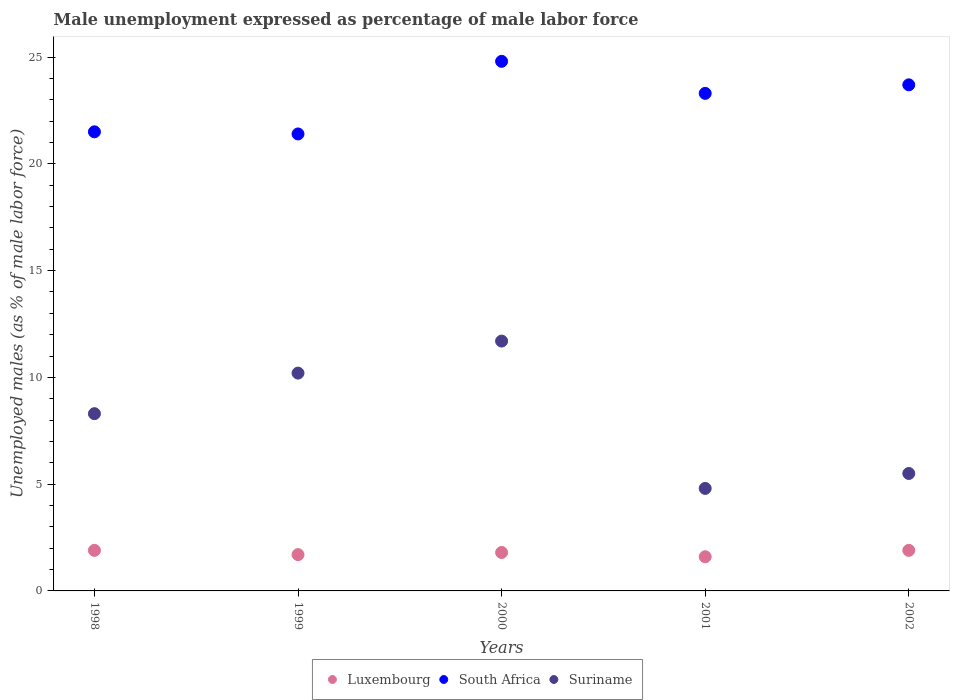What is the unemployment in males in in Suriname in 1999?
Your response must be concise. 10.2. Across all years, what is the maximum unemployment in males in in Luxembourg?
Offer a terse response. 1.9. Across all years, what is the minimum unemployment in males in in Suriname?
Your answer should be compact. 4.8. What is the total unemployment in males in in Luxembourg in the graph?
Your response must be concise. 8.9. What is the difference between the unemployment in males in in Luxembourg in 1998 and that in 2000?
Ensure brevity in your answer.  0.1. What is the difference between the unemployment in males in in Suriname in 1998 and the unemployment in males in in Luxembourg in 2002?
Your response must be concise. 6.4. What is the average unemployment in males in in Suriname per year?
Offer a terse response. 8.1. In the year 2000, what is the difference between the unemployment in males in in South Africa and unemployment in males in in Suriname?
Give a very brief answer. 13.1. What is the ratio of the unemployment in males in in Suriname in 1998 to that in 2001?
Ensure brevity in your answer.  1.73. Is the unemployment in males in in South Africa in 2000 less than that in 2002?
Your answer should be compact. No. What is the difference between the highest and the second highest unemployment in males in in Suriname?
Give a very brief answer. 1.5. What is the difference between the highest and the lowest unemployment in males in in South Africa?
Your answer should be very brief. 3.4. In how many years, is the unemployment in males in in Suriname greater than the average unemployment in males in in Suriname taken over all years?
Keep it short and to the point. 3. Is it the case that in every year, the sum of the unemployment in males in in Suriname and unemployment in males in in South Africa  is greater than the unemployment in males in in Luxembourg?
Provide a succinct answer. Yes. Is the unemployment in males in in Suriname strictly less than the unemployment in males in in South Africa over the years?
Offer a terse response. Yes. How many dotlines are there?
Provide a short and direct response. 3. How many years are there in the graph?
Provide a short and direct response. 5. What is the difference between two consecutive major ticks on the Y-axis?
Provide a short and direct response. 5. Are the values on the major ticks of Y-axis written in scientific E-notation?
Provide a succinct answer. No. Does the graph contain grids?
Your answer should be very brief. No. Where does the legend appear in the graph?
Give a very brief answer. Bottom center. What is the title of the graph?
Provide a short and direct response. Male unemployment expressed as percentage of male labor force. Does "Cameroon" appear as one of the legend labels in the graph?
Provide a succinct answer. No. What is the label or title of the Y-axis?
Provide a succinct answer. Unemployed males (as % of male labor force). What is the Unemployed males (as % of male labor force) of Luxembourg in 1998?
Your answer should be very brief. 1.9. What is the Unemployed males (as % of male labor force) in South Africa in 1998?
Your answer should be very brief. 21.5. What is the Unemployed males (as % of male labor force) in Suriname in 1998?
Ensure brevity in your answer.  8.3. What is the Unemployed males (as % of male labor force) of Luxembourg in 1999?
Provide a succinct answer. 1.7. What is the Unemployed males (as % of male labor force) of South Africa in 1999?
Give a very brief answer. 21.4. What is the Unemployed males (as % of male labor force) of Suriname in 1999?
Provide a succinct answer. 10.2. What is the Unemployed males (as % of male labor force) of Luxembourg in 2000?
Your response must be concise. 1.8. What is the Unemployed males (as % of male labor force) of South Africa in 2000?
Keep it short and to the point. 24.8. What is the Unemployed males (as % of male labor force) in Suriname in 2000?
Keep it short and to the point. 11.7. What is the Unemployed males (as % of male labor force) of Luxembourg in 2001?
Your answer should be very brief. 1.6. What is the Unemployed males (as % of male labor force) in South Africa in 2001?
Provide a short and direct response. 23.3. What is the Unemployed males (as % of male labor force) of Suriname in 2001?
Your response must be concise. 4.8. What is the Unemployed males (as % of male labor force) in Luxembourg in 2002?
Your answer should be very brief. 1.9. What is the Unemployed males (as % of male labor force) of South Africa in 2002?
Offer a terse response. 23.7. What is the Unemployed males (as % of male labor force) in Suriname in 2002?
Your answer should be compact. 5.5. Across all years, what is the maximum Unemployed males (as % of male labor force) in Luxembourg?
Offer a very short reply. 1.9. Across all years, what is the maximum Unemployed males (as % of male labor force) in South Africa?
Your response must be concise. 24.8. Across all years, what is the maximum Unemployed males (as % of male labor force) in Suriname?
Your response must be concise. 11.7. Across all years, what is the minimum Unemployed males (as % of male labor force) of Luxembourg?
Ensure brevity in your answer.  1.6. Across all years, what is the minimum Unemployed males (as % of male labor force) of South Africa?
Provide a short and direct response. 21.4. Across all years, what is the minimum Unemployed males (as % of male labor force) in Suriname?
Your answer should be compact. 4.8. What is the total Unemployed males (as % of male labor force) in Luxembourg in the graph?
Your response must be concise. 8.9. What is the total Unemployed males (as % of male labor force) in South Africa in the graph?
Provide a succinct answer. 114.7. What is the total Unemployed males (as % of male labor force) of Suriname in the graph?
Give a very brief answer. 40.5. What is the difference between the Unemployed males (as % of male labor force) in South Africa in 1998 and that in 1999?
Ensure brevity in your answer.  0.1. What is the difference between the Unemployed males (as % of male labor force) of Luxembourg in 1998 and that in 2001?
Ensure brevity in your answer.  0.3. What is the difference between the Unemployed males (as % of male labor force) in Suriname in 1998 and that in 2001?
Your response must be concise. 3.5. What is the difference between the Unemployed males (as % of male labor force) of Luxembourg in 1999 and that in 2000?
Keep it short and to the point. -0.1. What is the difference between the Unemployed males (as % of male labor force) of Suriname in 1999 and that in 2001?
Offer a terse response. 5.4. What is the difference between the Unemployed males (as % of male labor force) in Luxembourg in 1999 and that in 2002?
Your answer should be very brief. -0.2. What is the difference between the Unemployed males (as % of male labor force) of South Africa in 2000 and that in 2001?
Offer a terse response. 1.5. What is the difference between the Unemployed males (as % of male labor force) in Luxembourg in 2000 and that in 2002?
Provide a succinct answer. -0.1. What is the difference between the Unemployed males (as % of male labor force) of Suriname in 2000 and that in 2002?
Your answer should be very brief. 6.2. What is the difference between the Unemployed males (as % of male labor force) of South Africa in 2001 and that in 2002?
Provide a short and direct response. -0.4. What is the difference between the Unemployed males (as % of male labor force) of Suriname in 2001 and that in 2002?
Offer a very short reply. -0.7. What is the difference between the Unemployed males (as % of male labor force) in Luxembourg in 1998 and the Unemployed males (as % of male labor force) in South Africa in 1999?
Your answer should be very brief. -19.5. What is the difference between the Unemployed males (as % of male labor force) in South Africa in 1998 and the Unemployed males (as % of male labor force) in Suriname in 1999?
Your answer should be compact. 11.3. What is the difference between the Unemployed males (as % of male labor force) in Luxembourg in 1998 and the Unemployed males (as % of male labor force) in South Africa in 2000?
Your answer should be compact. -22.9. What is the difference between the Unemployed males (as % of male labor force) of Luxembourg in 1998 and the Unemployed males (as % of male labor force) of Suriname in 2000?
Your answer should be compact. -9.8. What is the difference between the Unemployed males (as % of male labor force) in South Africa in 1998 and the Unemployed males (as % of male labor force) in Suriname in 2000?
Offer a terse response. 9.8. What is the difference between the Unemployed males (as % of male labor force) of Luxembourg in 1998 and the Unemployed males (as % of male labor force) of South Africa in 2001?
Your answer should be compact. -21.4. What is the difference between the Unemployed males (as % of male labor force) in Luxembourg in 1998 and the Unemployed males (as % of male labor force) in Suriname in 2001?
Give a very brief answer. -2.9. What is the difference between the Unemployed males (as % of male labor force) in South Africa in 1998 and the Unemployed males (as % of male labor force) in Suriname in 2001?
Ensure brevity in your answer.  16.7. What is the difference between the Unemployed males (as % of male labor force) in Luxembourg in 1998 and the Unemployed males (as % of male labor force) in South Africa in 2002?
Provide a short and direct response. -21.8. What is the difference between the Unemployed males (as % of male labor force) of Luxembourg in 1999 and the Unemployed males (as % of male labor force) of South Africa in 2000?
Give a very brief answer. -23.1. What is the difference between the Unemployed males (as % of male labor force) in Luxembourg in 1999 and the Unemployed males (as % of male labor force) in Suriname in 2000?
Provide a succinct answer. -10. What is the difference between the Unemployed males (as % of male labor force) in Luxembourg in 1999 and the Unemployed males (as % of male labor force) in South Africa in 2001?
Ensure brevity in your answer.  -21.6. What is the difference between the Unemployed males (as % of male labor force) of Luxembourg in 1999 and the Unemployed males (as % of male labor force) of Suriname in 2001?
Ensure brevity in your answer.  -3.1. What is the difference between the Unemployed males (as % of male labor force) of Luxembourg in 2000 and the Unemployed males (as % of male labor force) of South Africa in 2001?
Provide a short and direct response. -21.5. What is the difference between the Unemployed males (as % of male labor force) of Luxembourg in 2000 and the Unemployed males (as % of male labor force) of South Africa in 2002?
Give a very brief answer. -21.9. What is the difference between the Unemployed males (as % of male labor force) of South Africa in 2000 and the Unemployed males (as % of male labor force) of Suriname in 2002?
Your response must be concise. 19.3. What is the difference between the Unemployed males (as % of male labor force) of Luxembourg in 2001 and the Unemployed males (as % of male labor force) of South Africa in 2002?
Keep it short and to the point. -22.1. What is the difference between the Unemployed males (as % of male labor force) in Luxembourg in 2001 and the Unemployed males (as % of male labor force) in Suriname in 2002?
Provide a succinct answer. -3.9. What is the average Unemployed males (as % of male labor force) in Luxembourg per year?
Your answer should be compact. 1.78. What is the average Unemployed males (as % of male labor force) of South Africa per year?
Make the answer very short. 22.94. In the year 1998, what is the difference between the Unemployed males (as % of male labor force) of Luxembourg and Unemployed males (as % of male labor force) of South Africa?
Give a very brief answer. -19.6. In the year 1998, what is the difference between the Unemployed males (as % of male labor force) of Luxembourg and Unemployed males (as % of male labor force) of Suriname?
Offer a very short reply. -6.4. In the year 1999, what is the difference between the Unemployed males (as % of male labor force) of Luxembourg and Unemployed males (as % of male labor force) of South Africa?
Your answer should be compact. -19.7. In the year 1999, what is the difference between the Unemployed males (as % of male labor force) of Luxembourg and Unemployed males (as % of male labor force) of Suriname?
Offer a terse response. -8.5. In the year 1999, what is the difference between the Unemployed males (as % of male labor force) in South Africa and Unemployed males (as % of male labor force) in Suriname?
Your response must be concise. 11.2. In the year 2000, what is the difference between the Unemployed males (as % of male labor force) in Luxembourg and Unemployed males (as % of male labor force) in South Africa?
Offer a very short reply. -23. In the year 2000, what is the difference between the Unemployed males (as % of male labor force) of South Africa and Unemployed males (as % of male labor force) of Suriname?
Offer a very short reply. 13.1. In the year 2001, what is the difference between the Unemployed males (as % of male labor force) of Luxembourg and Unemployed males (as % of male labor force) of South Africa?
Provide a short and direct response. -21.7. In the year 2001, what is the difference between the Unemployed males (as % of male labor force) in South Africa and Unemployed males (as % of male labor force) in Suriname?
Your response must be concise. 18.5. In the year 2002, what is the difference between the Unemployed males (as % of male labor force) in Luxembourg and Unemployed males (as % of male labor force) in South Africa?
Offer a very short reply. -21.8. What is the ratio of the Unemployed males (as % of male labor force) in Luxembourg in 1998 to that in 1999?
Keep it short and to the point. 1.12. What is the ratio of the Unemployed males (as % of male labor force) of South Africa in 1998 to that in 1999?
Provide a succinct answer. 1. What is the ratio of the Unemployed males (as % of male labor force) of Suriname in 1998 to that in 1999?
Your answer should be compact. 0.81. What is the ratio of the Unemployed males (as % of male labor force) of Luxembourg in 1998 to that in 2000?
Provide a short and direct response. 1.06. What is the ratio of the Unemployed males (as % of male labor force) in South Africa in 1998 to that in 2000?
Make the answer very short. 0.87. What is the ratio of the Unemployed males (as % of male labor force) of Suriname in 1998 to that in 2000?
Make the answer very short. 0.71. What is the ratio of the Unemployed males (as % of male labor force) in Luxembourg in 1998 to that in 2001?
Your answer should be very brief. 1.19. What is the ratio of the Unemployed males (as % of male labor force) in South Africa in 1998 to that in 2001?
Make the answer very short. 0.92. What is the ratio of the Unemployed males (as % of male labor force) in Suriname in 1998 to that in 2001?
Your response must be concise. 1.73. What is the ratio of the Unemployed males (as % of male labor force) of Luxembourg in 1998 to that in 2002?
Your answer should be very brief. 1. What is the ratio of the Unemployed males (as % of male labor force) of South Africa in 1998 to that in 2002?
Give a very brief answer. 0.91. What is the ratio of the Unemployed males (as % of male labor force) of Suriname in 1998 to that in 2002?
Offer a terse response. 1.51. What is the ratio of the Unemployed males (as % of male labor force) in Luxembourg in 1999 to that in 2000?
Give a very brief answer. 0.94. What is the ratio of the Unemployed males (as % of male labor force) in South Africa in 1999 to that in 2000?
Ensure brevity in your answer.  0.86. What is the ratio of the Unemployed males (as % of male labor force) of Suriname in 1999 to that in 2000?
Offer a very short reply. 0.87. What is the ratio of the Unemployed males (as % of male labor force) in South Africa in 1999 to that in 2001?
Ensure brevity in your answer.  0.92. What is the ratio of the Unemployed males (as % of male labor force) in Suriname in 1999 to that in 2001?
Make the answer very short. 2.12. What is the ratio of the Unemployed males (as % of male labor force) in Luxembourg in 1999 to that in 2002?
Make the answer very short. 0.89. What is the ratio of the Unemployed males (as % of male labor force) of South Africa in 1999 to that in 2002?
Keep it short and to the point. 0.9. What is the ratio of the Unemployed males (as % of male labor force) in Suriname in 1999 to that in 2002?
Offer a terse response. 1.85. What is the ratio of the Unemployed males (as % of male labor force) in South Africa in 2000 to that in 2001?
Ensure brevity in your answer.  1.06. What is the ratio of the Unemployed males (as % of male labor force) in Suriname in 2000 to that in 2001?
Make the answer very short. 2.44. What is the ratio of the Unemployed males (as % of male labor force) of Luxembourg in 2000 to that in 2002?
Your answer should be very brief. 0.95. What is the ratio of the Unemployed males (as % of male labor force) in South Africa in 2000 to that in 2002?
Keep it short and to the point. 1.05. What is the ratio of the Unemployed males (as % of male labor force) of Suriname in 2000 to that in 2002?
Offer a very short reply. 2.13. What is the ratio of the Unemployed males (as % of male labor force) in Luxembourg in 2001 to that in 2002?
Keep it short and to the point. 0.84. What is the ratio of the Unemployed males (as % of male labor force) in South Africa in 2001 to that in 2002?
Your response must be concise. 0.98. What is the ratio of the Unemployed males (as % of male labor force) of Suriname in 2001 to that in 2002?
Ensure brevity in your answer.  0.87. What is the difference between the highest and the second highest Unemployed males (as % of male labor force) of Suriname?
Make the answer very short. 1.5. What is the difference between the highest and the lowest Unemployed males (as % of male labor force) of Luxembourg?
Provide a succinct answer. 0.3. What is the difference between the highest and the lowest Unemployed males (as % of male labor force) in South Africa?
Your answer should be compact. 3.4. 